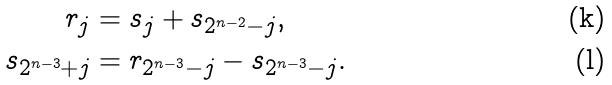<formula> <loc_0><loc_0><loc_500><loc_500>r _ { j } & = s _ { j } + s _ { 2 ^ { n - 2 } - j } , \\ s _ { 2 ^ { n - 3 } + j } & = r _ { 2 ^ { n - 3 } - j } - s _ { 2 ^ { n - 3 } - j } .</formula> 